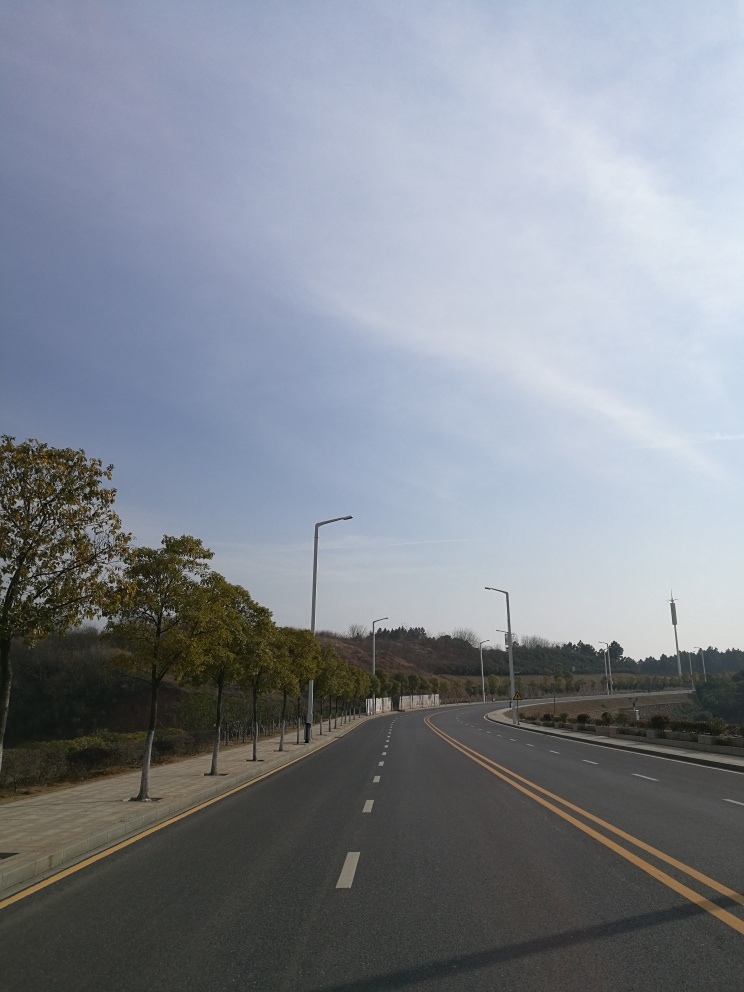What time of day does this image seem to capture? The image appears to capture a quiet moment during the day, given the natural daylight and the long shadows indicating either early morning or late afternoon. 